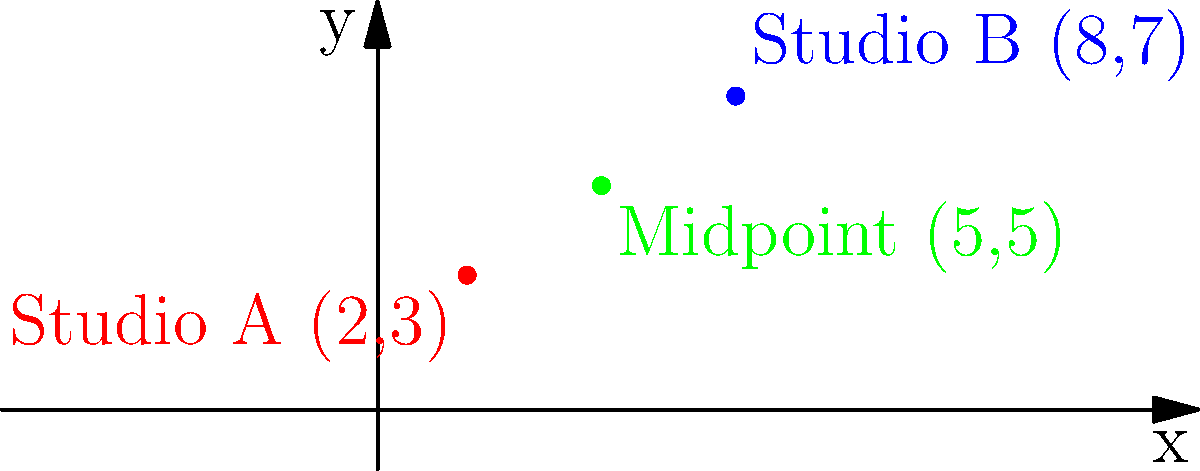You're planning to set up a new recording studio equidistant from two existing studios. Studio A is located at coordinates (2,3) and Studio B is at (8,7) in the city's coordinate system. What are the coordinates of the ideal location for your new studio? To find the midpoint between two points, we use the midpoint formula:

$$ \text{Midpoint} = (\frac{x_1 + x_2}{2}, \frac{y_1 + y_2}{2}) $$

Where $(x_1, y_1)$ are the coordinates of the first point and $(x_2, y_2)$ are the coordinates of the second point.

1. Identify the coordinates:
   Studio A: $(x_1, y_1) = (2, 3)$
   Studio B: $(x_2, y_2) = (8, 7)$

2. Calculate the x-coordinate of the midpoint:
   $$ x = \frac{x_1 + x_2}{2} = \frac{2 + 8}{2} = \frac{10}{2} = 5 $$

3. Calculate the y-coordinate of the midpoint:
   $$ y = \frac{y_1 + y_2}{2} = \frac{3 + 7}{2} = \frac{10}{2} = 5 $$

4. Combine the results:
   The midpoint coordinates are $(5, 5)$

Therefore, the ideal location for your new studio is at coordinates (5,5).
Answer: (5,5) 